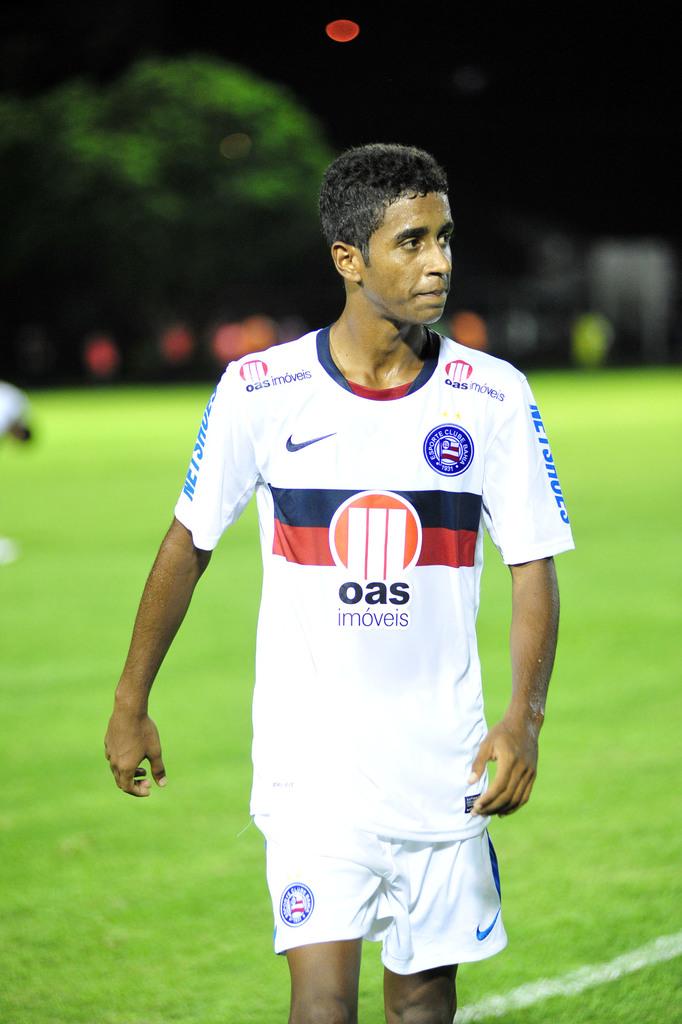What team does this man play for?
Make the answer very short. Oas. How many i's are in the middle of the jersey?
Offer a very short reply. 2. 